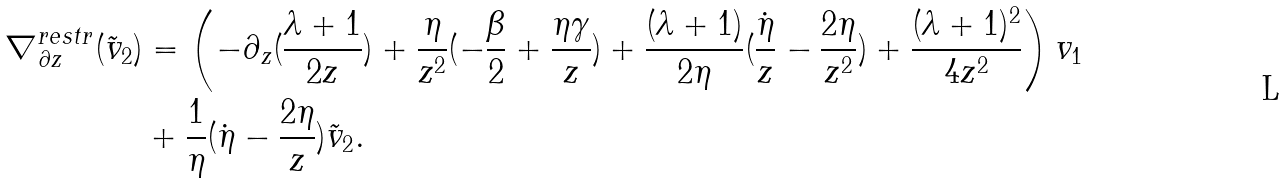<formula> <loc_0><loc_0><loc_500><loc_500>\nabla ^ { r e s t r } _ { \partial z } ( \tilde { v } _ { 2 } ) & = \left ( - \partial _ { z } ( \frac { \lambda + 1 } { 2 z } ) + \frac { \eta } { z ^ { 2 } } ( - \frac { \beta } { 2 } + \frac { \eta \gamma } { z } ) + \frac { ( \lambda + 1 ) } { 2 \eta } ( \frac { \dot { \eta } } { z } - \frac { 2 \eta } { z ^ { 2 } } ) + \frac { ( \lambda + 1 ) ^ { 2 } } { 4 z ^ { 2 } } \right ) v _ { 1 } \\ & + \frac { 1 } { \eta } ( \dot { \eta } - \frac { 2 \eta } { z } ) \tilde { v } _ { 2 } .</formula> 